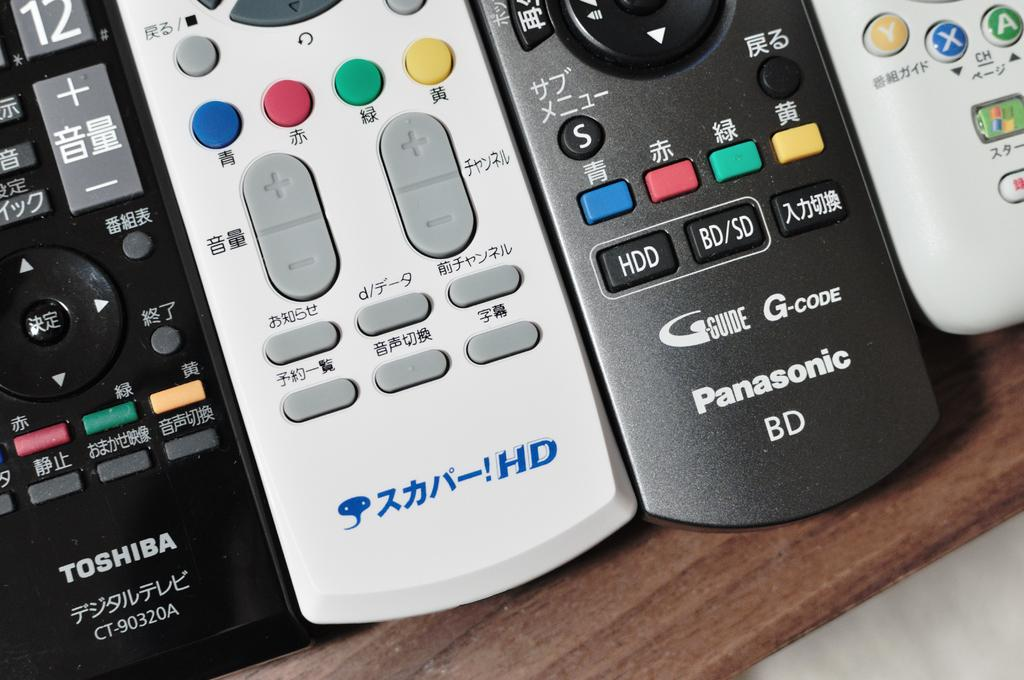Provide a one-sentence caption for the provided image. several tv remotes, such as toshiba and panasonic. 